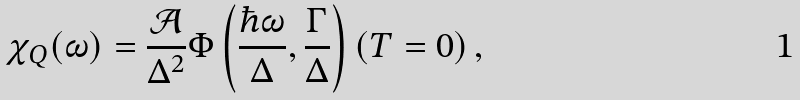<formula> <loc_0><loc_0><loc_500><loc_500>\chi _ { Q } ( \omega ) = \frac { \mathcal { A } } { \Delta ^ { 2 } } \Phi \left ( \frac { \hbar { \omega } } { \Delta } , \frac { \Gamma } { \Delta } \right ) ( T = 0 ) \, ,</formula> 